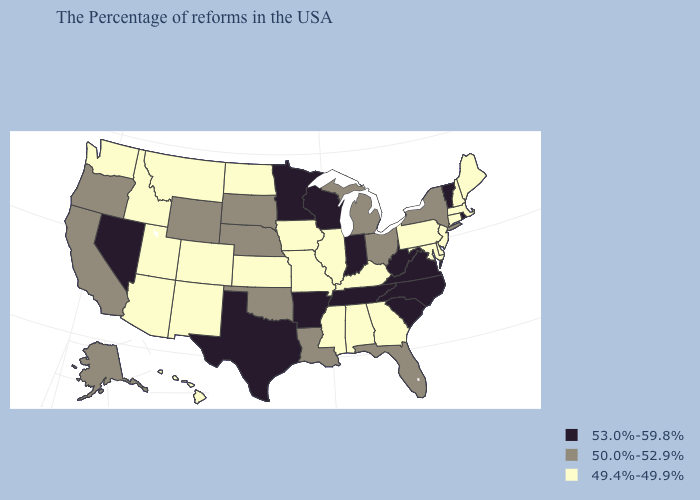Among the states that border Arkansas , does Tennessee have the highest value?
Be succinct. Yes. Which states have the lowest value in the MidWest?
Give a very brief answer. Illinois, Missouri, Iowa, Kansas, North Dakota. Does Kansas have the same value as Montana?
Write a very short answer. Yes. Among the states that border Alabama , does Tennessee have the highest value?
Be succinct. Yes. Name the states that have a value in the range 50.0%-52.9%?
Short answer required. New York, Ohio, Florida, Michigan, Louisiana, Nebraska, Oklahoma, South Dakota, Wyoming, California, Oregon, Alaska. What is the value of Georgia?
Give a very brief answer. 49.4%-49.9%. What is the value of Maryland?
Write a very short answer. 49.4%-49.9%. What is the highest value in states that border Utah?
Keep it brief. 53.0%-59.8%. Does South Carolina have the lowest value in the USA?
Give a very brief answer. No. Among the states that border Virginia , which have the lowest value?
Short answer required. Maryland, Kentucky. Name the states that have a value in the range 53.0%-59.8%?
Keep it brief. Rhode Island, Vermont, Virginia, North Carolina, South Carolina, West Virginia, Indiana, Tennessee, Wisconsin, Arkansas, Minnesota, Texas, Nevada. Name the states that have a value in the range 53.0%-59.8%?
Be succinct. Rhode Island, Vermont, Virginia, North Carolina, South Carolina, West Virginia, Indiana, Tennessee, Wisconsin, Arkansas, Minnesota, Texas, Nevada. Among the states that border Kansas , which have the highest value?
Answer briefly. Nebraska, Oklahoma. Among the states that border Colorado , does New Mexico have the highest value?
Give a very brief answer. No. Which states have the highest value in the USA?
Concise answer only. Rhode Island, Vermont, Virginia, North Carolina, South Carolina, West Virginia, Indiana, Tennessee, Wisconsin, Arkansas, Minnesota, Texas, Nevada. 